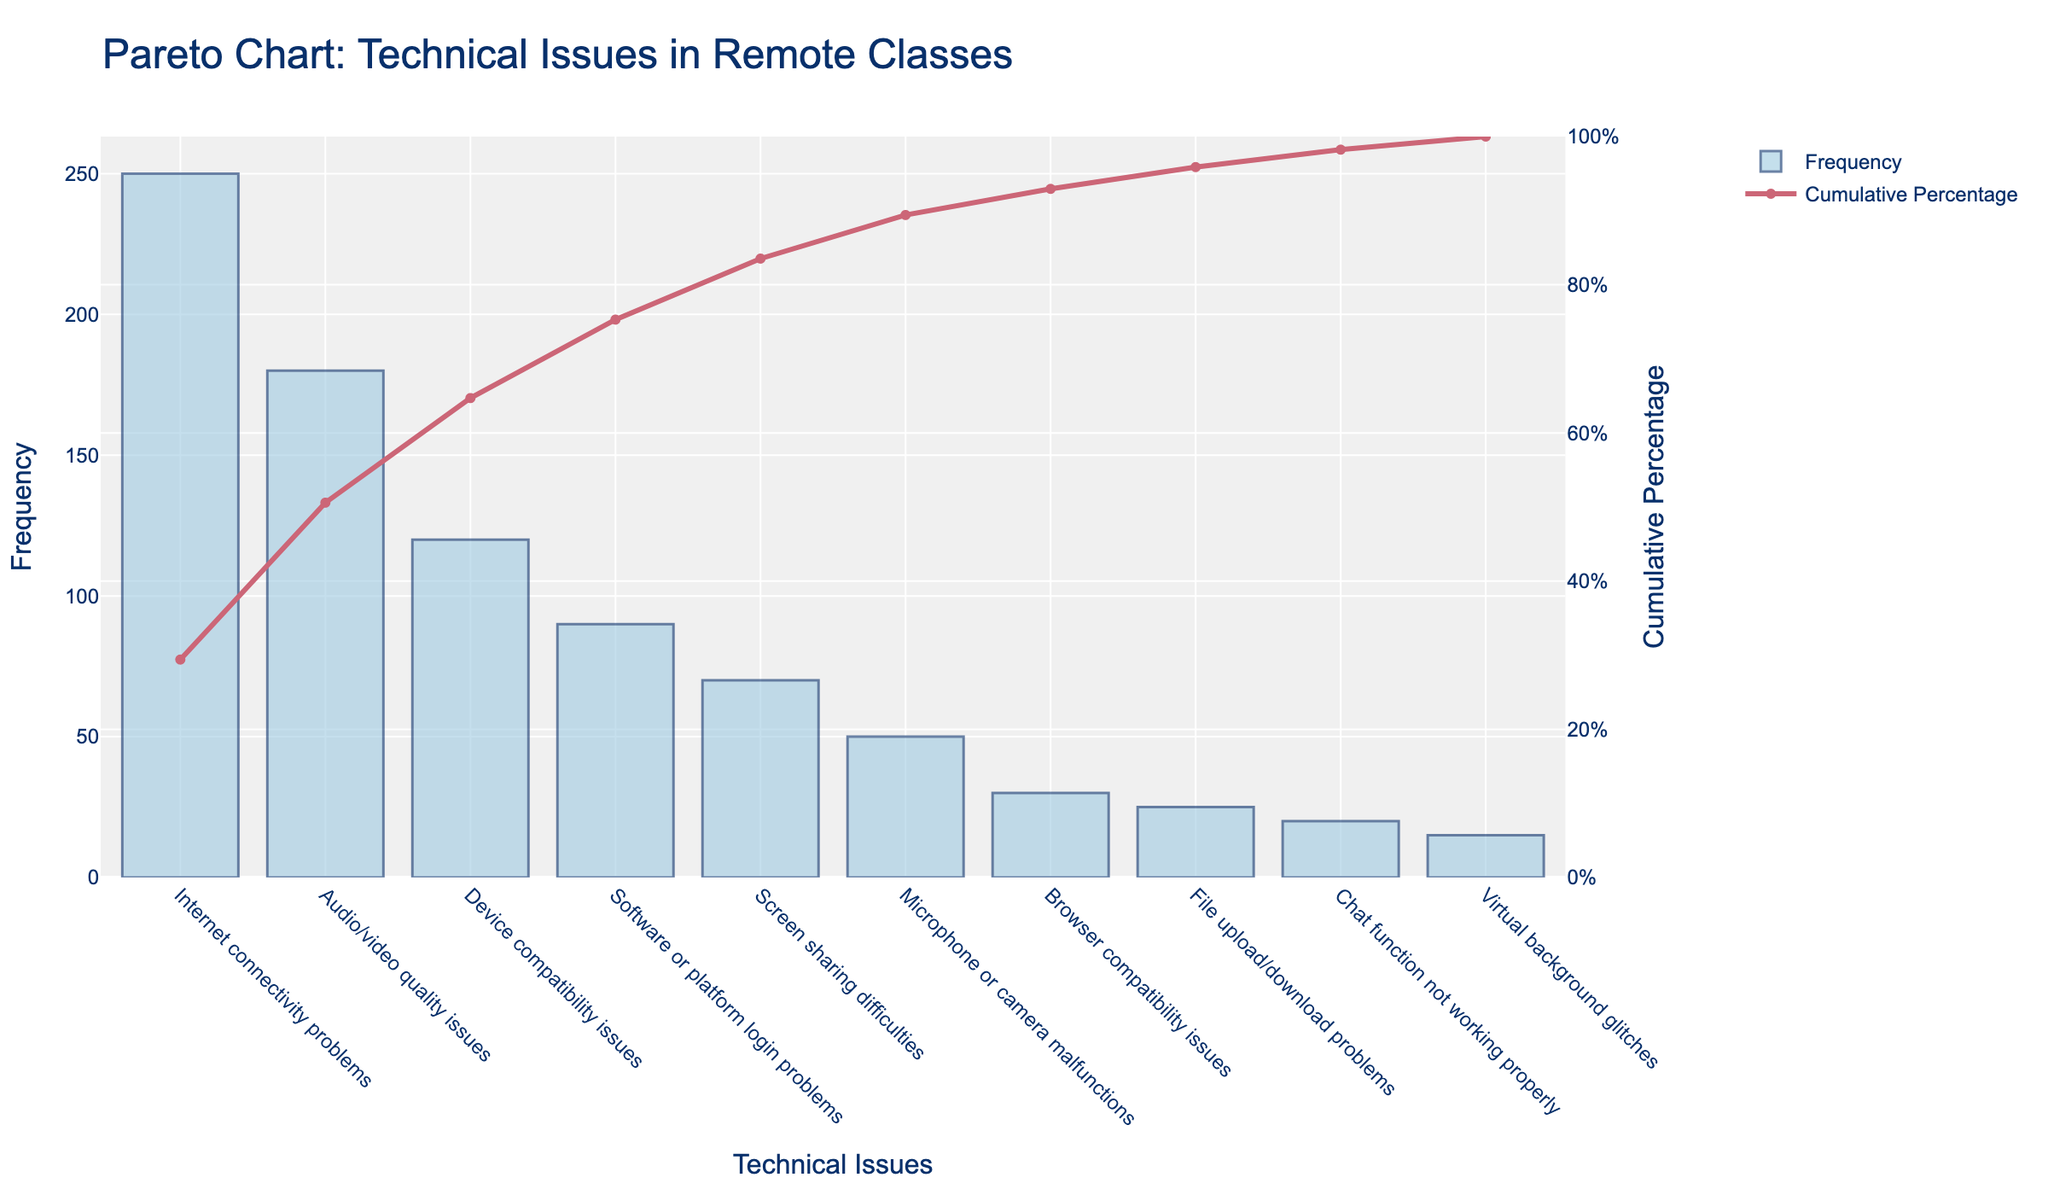What is the title of the chart? The title is usually the largest text at the top of the chart. In this case, it reads "Pareto Chart: Technical Issues in Remote Classes".
Answer: Pareto Chart: Technical Issues in Remote Classes How many types of technical issues are listed in the chart? The x-axis of the chart lists all the technical issues. By counting them, we can see there are 10 different types.
Answer: 10 Which technical issue has the highest frequency? The bar with the greatest height represents the most frequent issue. Here, "Internet connectivity problems" has the highest frequency.
Answer: Internet connectivity problems What is the cumulative percentage for "Device compatibility issues"? The red line represents the cumulative percentage, and the specific value for "Device compatibility issues" can be found where it intersects the y-axis on the right.
Answer: 72.67% What are the top three technical issues based on frequency? The three tallest bars represent the top three issues. By looking at the x-axis labels, they are "Internet connectivity problems", "Audio/video quality issues", and "Device compatibility issues".
Answer: Internet connectivity problems, Audio/video quality issues, Device compatibility issues How much more frequent are internet connectivity problems compared to software or platform login problems? Locate the bars for "Internet connectivity problems" and "Software or platform login problems". Subtract the height of the latter from the former: 250 - 90 = 160.
Answer: 160 For what percentage of total issues does the top issue (Internet connectivity problems) account? The frequency of the top issue is 250. Divide this by the total number of issues and multiply by 100: (250 / (250 + 180 + 120 + 90 + 70 + 50 + 30 + 25 + 20 + 15)) * 100 = 34.25%.
Answer: 34.25% Which issue lies closest to the 50% cumulative percentage mark? Identify where the red line crosses closest to the 50% mark on the right y-axis, which aligns with "Audio/video quality issues" as its cumulative percentage is near 50%.
Answer: Audio/video quality issues What is the combined frequency of issues with less than 40 occurrences? Sum the frequencies of the issues "Browser compatibility issues", "File upload/download problems", "Chat function not working properly", and "Virtual background glitches" (30 + 25 + 20 + 15) = 90.
Answer: 90 Which issue is represented by the shortest bar on the chart? The shortest bar indicates the least frequent issue. Looking at the chart, "Virtual background glitches" is the shortest.
Answer: Virtual background glitches 